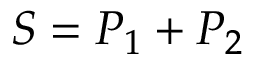Convert formula to latex. <formula><loc_0><loc_0><loc_500><loc_500>S = P _ { 1 } + P _ { 2 }</formula> 